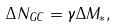<formula> <loc_0><loc_0><loc_500><loc_500>\Delta N _ { G C } = \gamma \Delta M _ { * } ,</formula> 